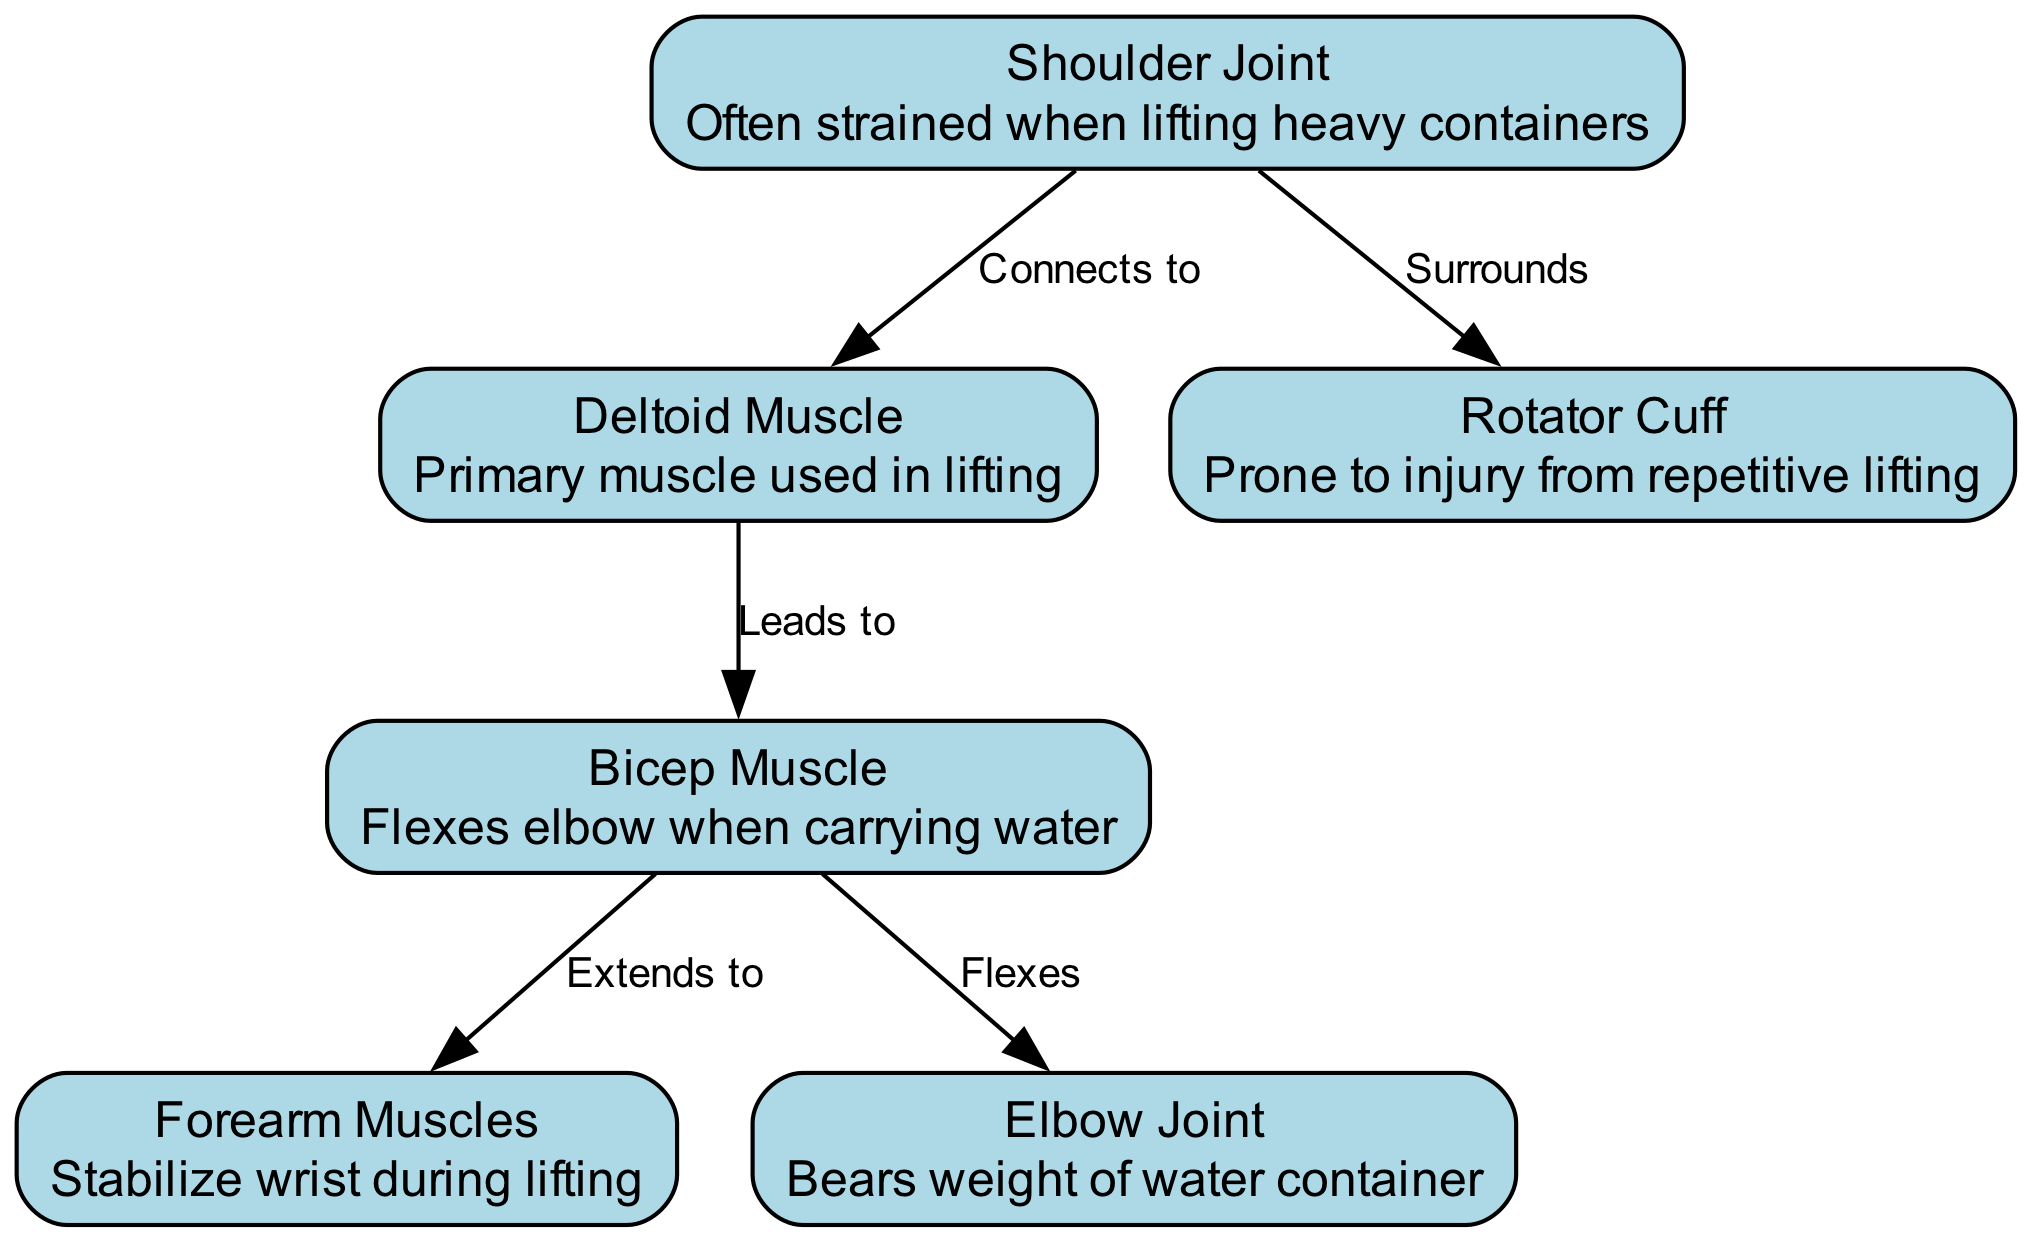What is the primary muscle used in lifting? The diagram shows the deltoid muscle with the description highlighting its role as the primary muscle used in lifting.
Answer: Deltoid Muscle Which joint is often strained when lifting heavy containers? The diagram highlights the shoulder joint with the description indicating it is often strained when lifting heavy containers.
Answer: Shoulder Joint How many muscles are involved in lifting as per the diagram? The diagram lists three muscles involved in lifting: deltoid, bicep, and forearm.
Answer: Three What does the bicep muscle do when carrying water? The description next to the bicep muscle indicates it flexes the elbow when carrying water, showing its function in this action.
Answer: Flexes elbow Which structure surrounds the shoulder joint according to the diagram? The diagram specifies that the rotator cuff surrounds the shoulder joint, indicating its protective role.
Answer: Rotator Cuff What muscle stabilizes the wrist during lifting? According to the diagram, the forearm muscles are responsible for stabilizing the wrist during lifting activities.
Answer: Forearm Muscles How does the structure of the bicep relate to the elbow joint? The diagram indicates that the bicep muscle flexes the elbow joint, showing a direct functional relationship during lifting.
Answer: Flexes What injury is the rotator cuff prone to from repetitive lifting? The diagram describes the rotator cuff as prone to injury, specifically mentioning the risk associated with repetitive lifting actions.
Answer: Injury Which joint bears the weight of the water container? The elbow joint is highlighted in the diagram as bearing the weight of the water container, identifying its crucial role during lifting.
Answer: Elbow Joint 